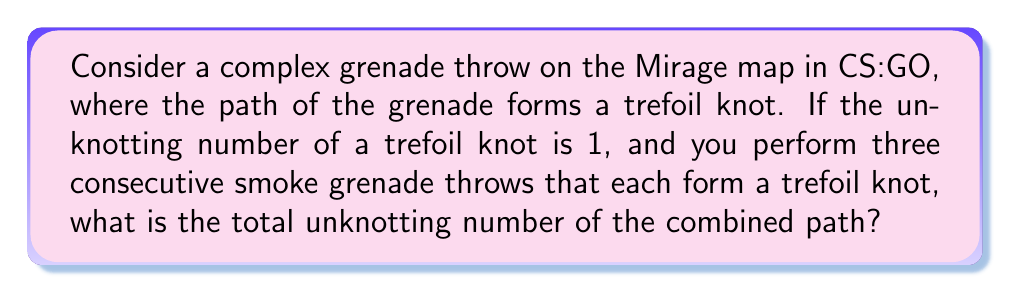Can you answer this question? Let's approach this step-by-step:

1) First, recall that the unknotting number of a knot is the minimum number of times the knot must pass through itself to become unknotted.

2) We are given that the unknotting number of a trefoil knot is 1. Let's denote this as:

   $U(\text{trefoil}) = 1$

3) In this scenario, we have three consecutive smoke grenade throws, each forming a trefoil knot. We can represent this as:

   $K = K_1 \# K_2 \# K_3$

   where $K$ is the combined knot, and $K_1$, $K_2$, and $K_3$ are individual trefoil knots.

4) An important property in knot theory is that for a connected sum of knots:

   $U(K_1 \# K_2) \leq U(K_1) + U(K_2)$

5) This property extends to multiple knots. For our case:

   $U(K) \leq U(K_1) + U(K_2) + U(K_3)$

6) Since each $K_i$ is a trefoil knot with unknotting number 1:

   $U(K) \leq 1 + 1 + 1 = 3$

7) However, this inequality is actually an equality for trefoil knots. The unknotting number of a connected sum of trefoil knots is exactly the sum of their individual unknotting numbers.

Therefore, the total unknotting number of the combined path is 3.
Answer: 3 